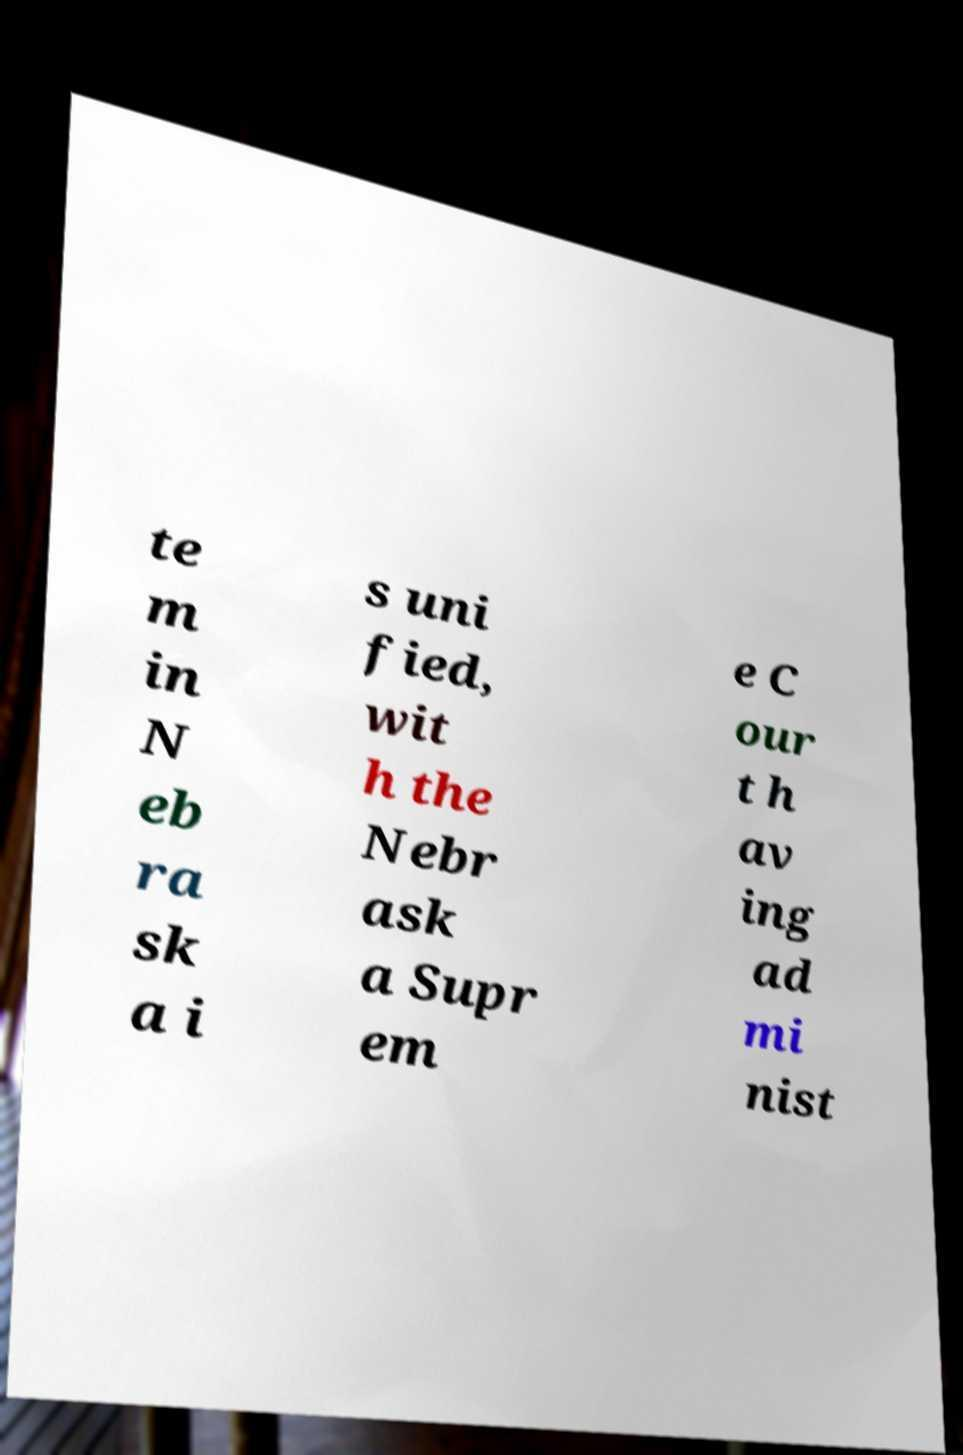Please read and relay the text visible in this image. What does it say? te m in N eb ra sk a i s uni fied, wit h the Nebr ask a Supr em e C our t h av ing ad mi nist 